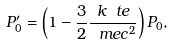<formula> <loc_0><loc_0><loc_500><loc_500>P _ { 0 } ^ { \prime } = \left ( 1 - \frac { 3 } { 2 } \frac { k \ t e } { \ m e c ^ { 2 } } \right ) P _ { 0 } ,</formula> 